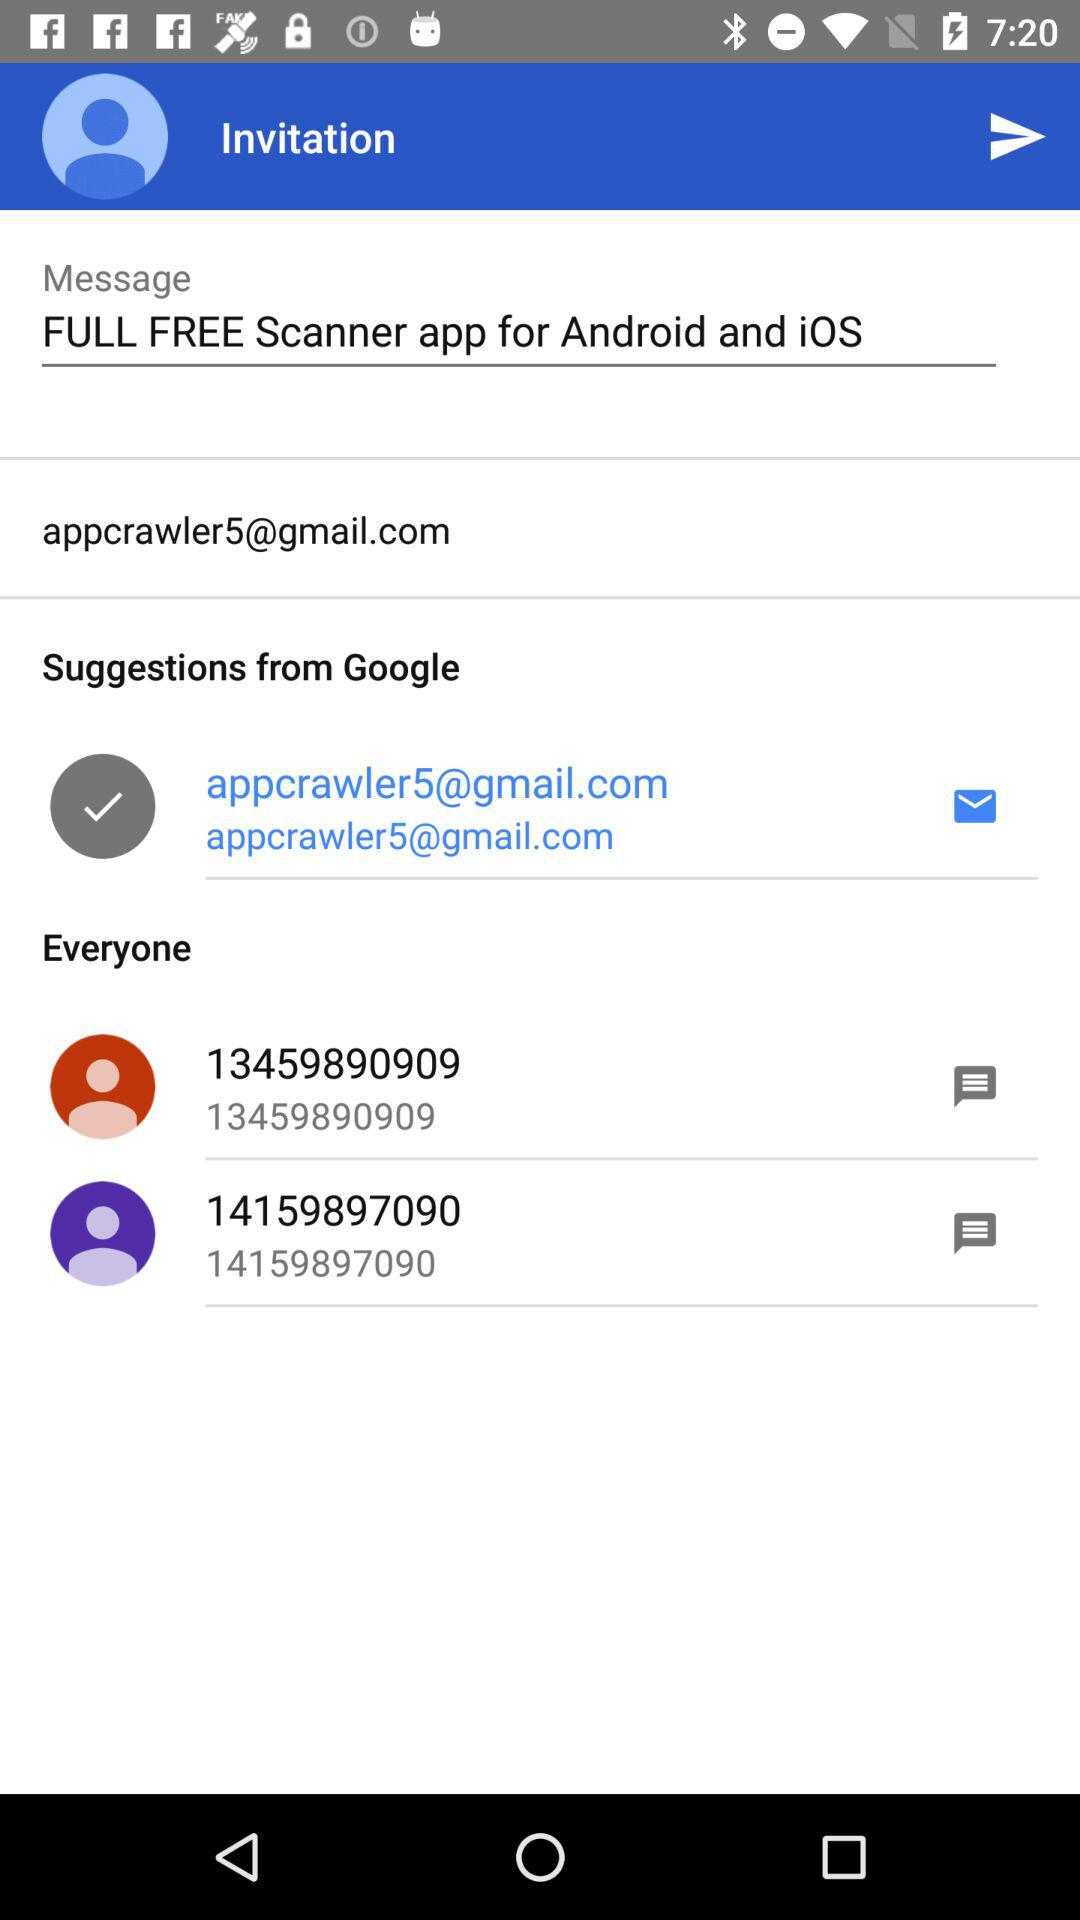How many people can the invitation be sent to?
When the provided information is insufficient, respond with <no answer>. <no answer> 